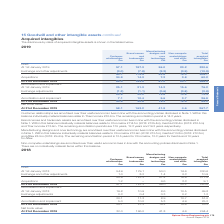According to Spirax Sarco Engineering Plc's financial document, How are non-complete undertakings amortised? amortised over their useful economic lives in line with the accounting policies disclosed in Note 1. The document states: "Customer relationships are amortised over their useful economic lives in line with the accounting policies disclosed in Note 1. Within this balance in..." Also, What do the individually material balances within the balance of brand names and trademark assets after amortisation relate to? The document contains multiple relevant values: Chromalox, Gestra, Thermocoax. From the document: "balance individually material balances relate to Chromalox £114.1m (2018: £125.4m), Gestra £28.4m (2018: £32.5m) and Thermocoax £13.6m. The remaining ..." Also, What are the different classes of acquired intangible assets in the table? The document contains multiple relevant values: Customer relationships, Brand names and trademarks, Manufacturing designs and core technology, Non-compete undertakings and other. From the document: "Brand names and trademarks £m Manufacturing designs and core technology £m Customer relationships £m Non-compete undertakings and other £m..." Additionally, Which class of acquired intangible assets shown in the table has the lowest amount of acquisitions? Non-compete undertakings and other. The document states: "Non-compete undertakings and other £m..." Also, can you calculate: What was the change in the amount of individually material balances under manufacturing designs and core technology for Aflex in 2019 from 2018? Based on the calculation: 8.5-9.4, the result is -0.9 (in millions). This is based on the information: "tra £10.8m (2018: £12.3m) and Aflex £8.5m (2018: £9.4m). The remaining amortisation period is 12.5 years for Chromalox, 12.3 years for Gestra and 10 year At 31st December 2019 30.9 30.6 19.2 18.5 99.2..." The key data points involved are: 8.5, 9.4. Also, can you calculate: What was the percentage change in the amount of individually material balances under manufacturing designs and core technology for Aflex in 2019 from 2018? To answer this question, I need to perform calculations using the financial data. The calculation is: (8.5-9.4)/9.4, which equals -9.57 (percentage). This is based on the information: "tra £10.8m (2018: £12.3m) and Aflex £8.5m (2018: £9.4m). The remaining amortisation period is 12.5 years for Chromalox, 12.3 years for Gestra and 10 year At 31st December 2019 30.9 30.6 19.2 18.5 99.2..." The key data points involved are: 8.5, 9.4. 